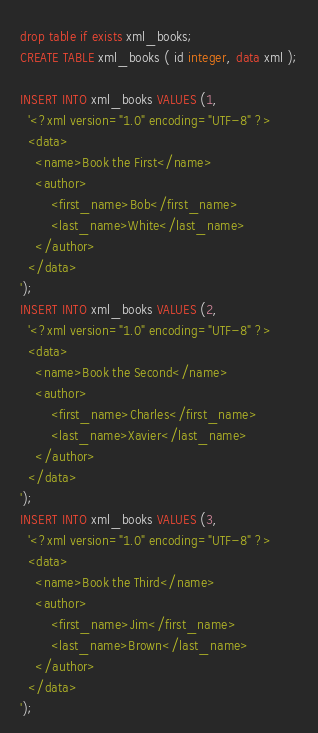Convert code to text. <code><loc_0><loc_0><loc_500><loc_500><_SQL_>drop table if exists xml_books;
CREATE TABLE xml_books ( id integer, data xml );

INSERT INTO xml_books VALUES (1,
  '<?xml version="1.0" encoding="UTF-8" ?>
  <data>
	<name>Book the First</name>
	<author>
		<first_name>Bob</first_name>
		<last_name>White</last_name>
	</author>
  </data>
');
INSERT INTO xml_books VALUES (2,
  '<?xml version="1.0" encoding="UTF-8" ?>
  <data>
	<name>Book the Second</name>
	<author>
		<first_name>Charles</first_name>
		<last_name>Xavier</last_name>
	</author>
  </data>
');
INSERT INTO xml_books VALUES (3,
  '<?xml version="1.0" encoding="UTF-8" ?>
  <data>
	<name>Book the Third</name>
	<author>
		<first_name>Jim</first_name>
		<last_name>Brown</last_name>
	</author>
  </data>
');
</code> 